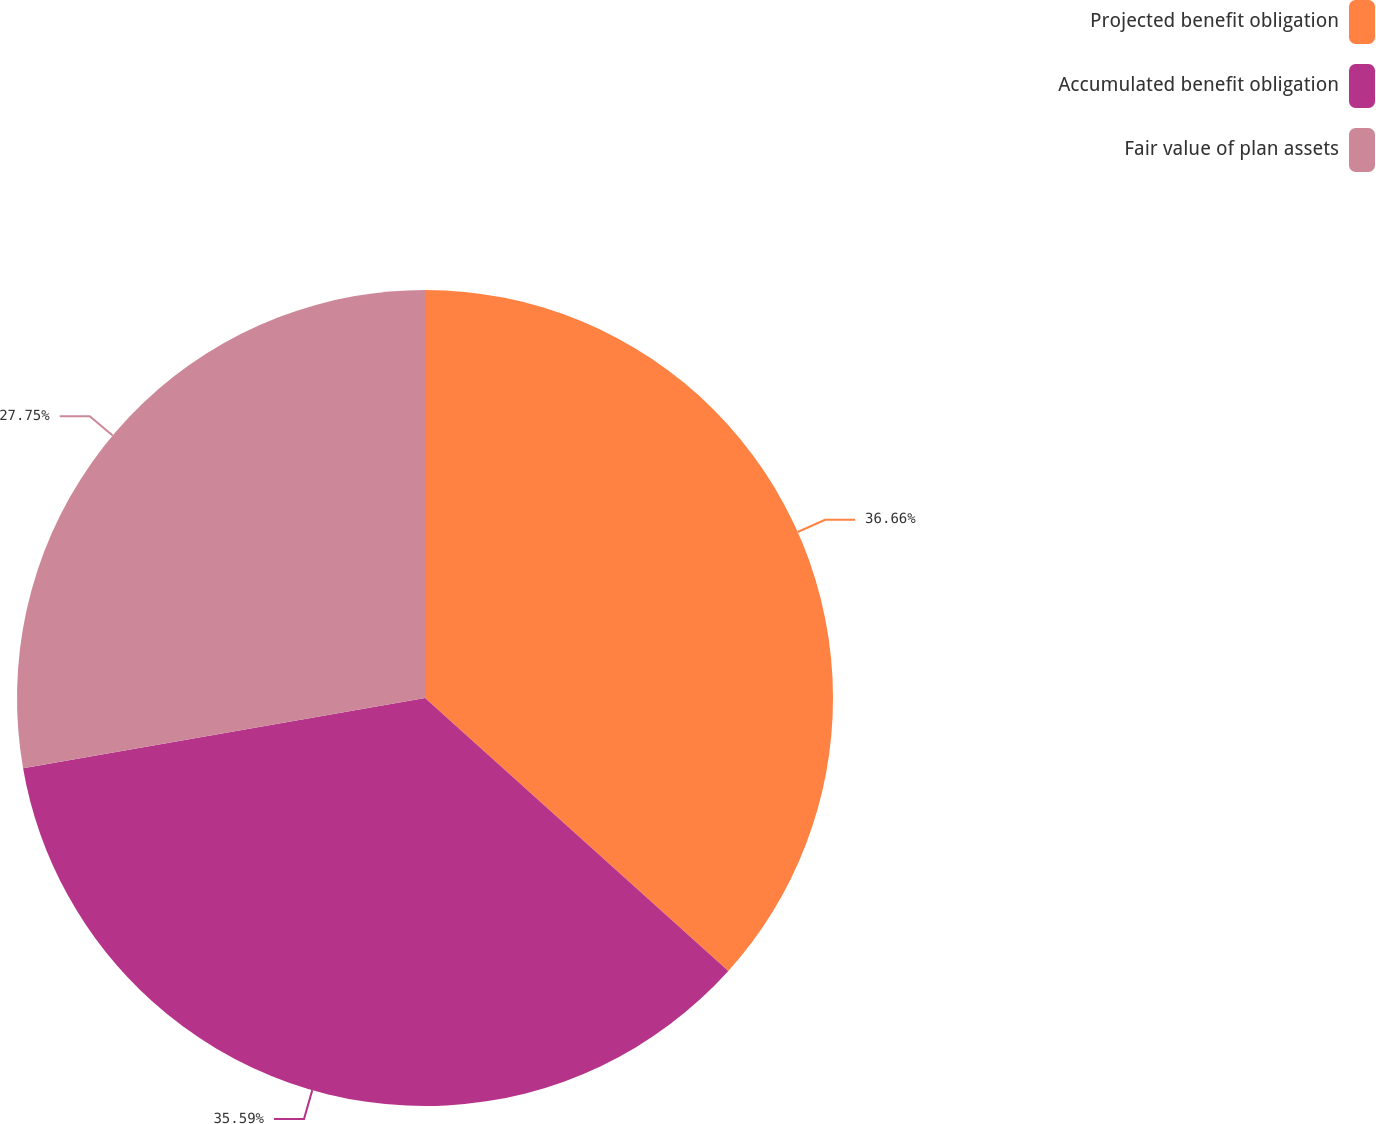Convert chart. <chart><loc_0><loc_0><loc_500><loc_500><pie_chart><fcel>Projected benefit obligation<fcel>Accumulated benefit obligation<fcel>Fair value of plan assets<nl><fcel>36.66%<fcel>35.59%<fcel>27.75%<nl></chart> 